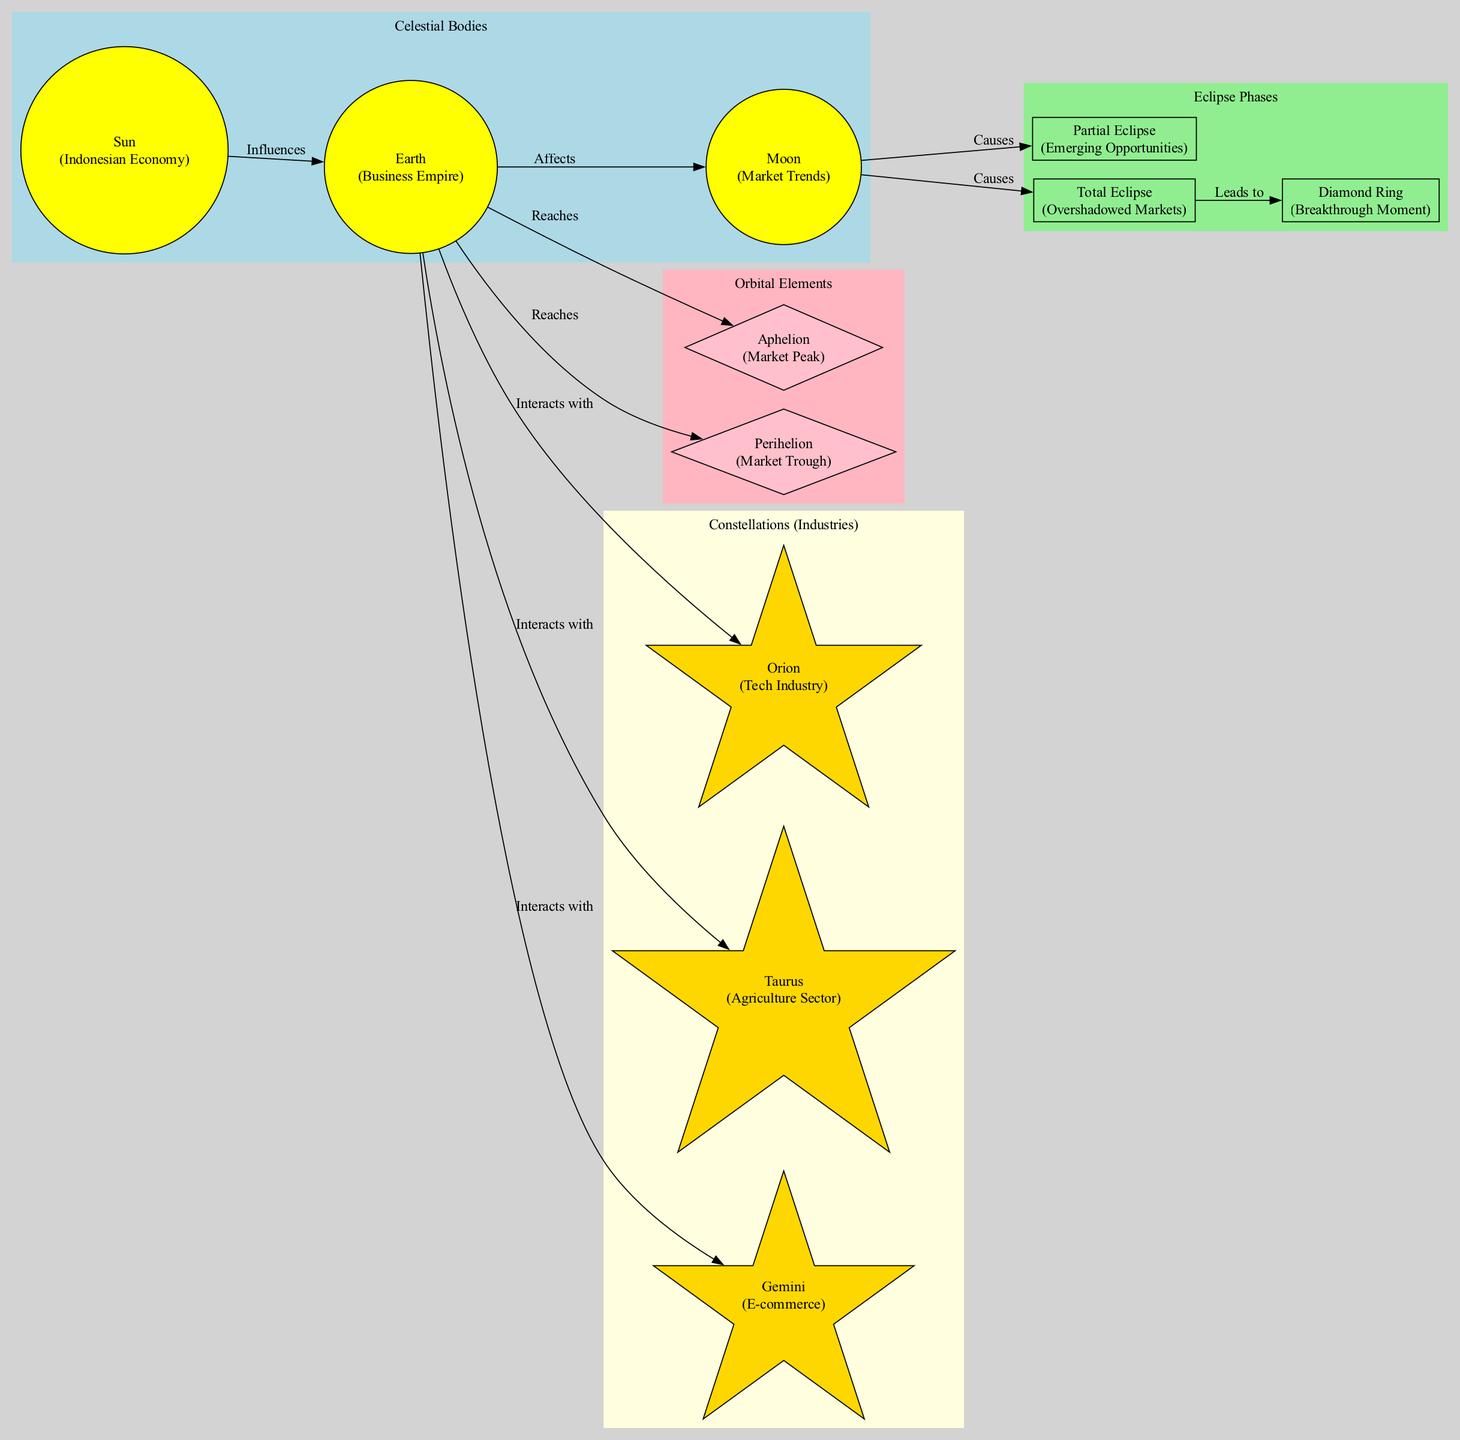What does the "Sun" represent? The "Sun" is labeled in the diagram as representing the "Indonesian Economy." This is a direct identification from the node designation within the celestial bodies' section.
Answer: Indonesian Economy How many celestial bodies are shown in the diagram? The diagram contains three celestial bodies: the Sun, Earth, and Moon. This count can be verified from the list of nodes presented in the celestial bodies' section.
Answer: 3 What leads to the "Diamond Ring"? The "Total Eclipse" is indicated as leading to the "Diamond Ring" in the diagram, represented by a direct edge connecting these two nodes. This establishes a clear relationship where the occurrence of a total eclipse results in a breakthrough moment.
Answer: Total Eclipse Which phase represents "Emerging Opportunities"? The phase labeled as "Partial Eclipse" corresponds to "Emerging Opportunities." This connection is explicitly stated in the eclipse phases section of the diagram.
Answer: Partial Eclipse What does "Perihelion" represent? "Perihelion" is indicated in the diagram as representing "Market Trough." This can be inferred directly from the labeling within the orbital elements section of the diagram.
Answer: Market Trough How does the "Moon" affect the "Earth"? The diagram specifies that the "Moon" affects the "Earth," which means the market trends directly influence the business empire. This relationship is shown through a directed edge from the Moon to the Earth.
Answer: Affects Which sector is represented by "Taurus"? The sector represented by "Taurus" is the "Agriculture Sector." This can be directly read from the constellation section of the diagram, where each constellation corresponds to a specific industry.
Answer: Agriculture Sector What is the relationship between the "Earth" and "Gemini"? The "Earth" interacts with "Gemini," which denotes the E-commerce sector. The diagram includes a directed edge showing this interaction, confirming the link between the business empire and this industry.
Answer: Interacts with How many eclipse phases are present in the diagram? The diagram features three eclipse phases: Partial Eclipse, Total Eclipse, and Diamond Ring. This total can be counted within the eclipse phases' section of the diagram.
Answer: 3 